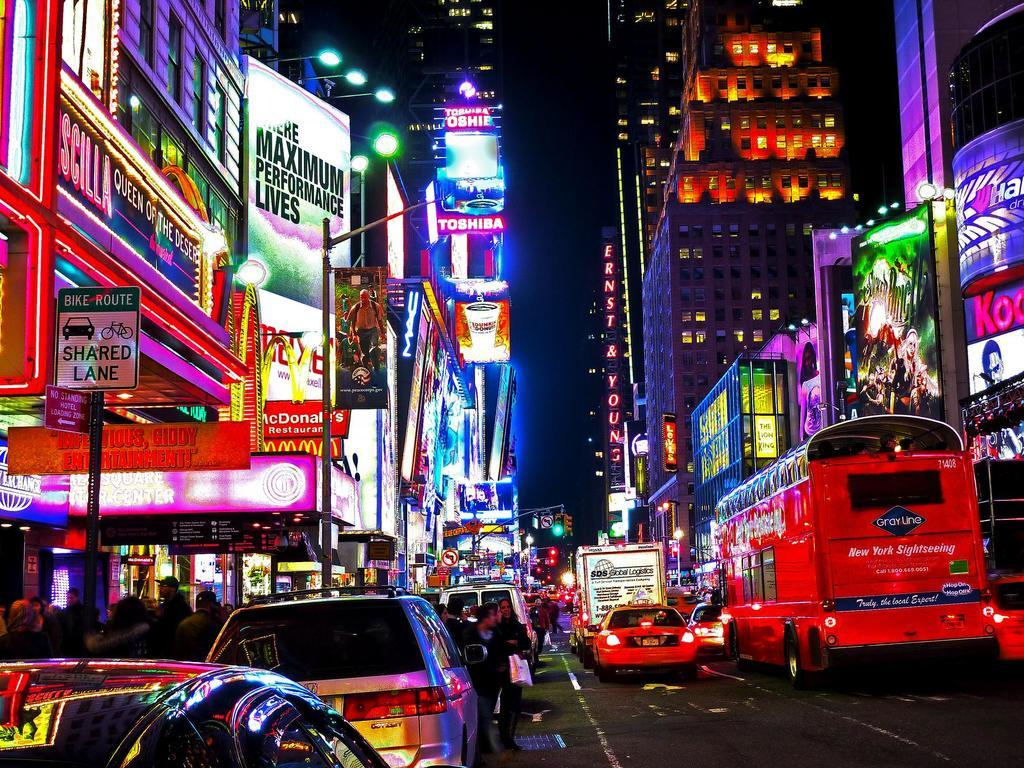Provide a one-sentence caption for the provided image. Night streetview with a McDonalds on the side. 